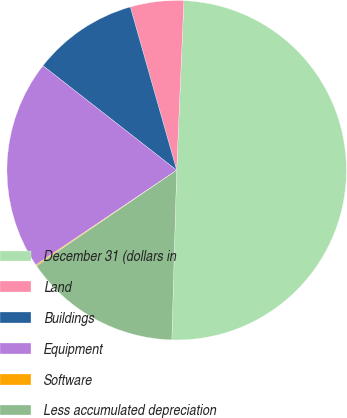Convert chart to OTSL. <chart><loc_0><loc_0><loc_500><loc_500><pie_chart><fcel>December 31 (dollars in<fcel>Land<fcel>Buildings<fcel>Equipment<fcel>Software<fcel>Less accumulated depreciation<nl><fcel>49.78%<fcel>5.08%<fcel>10.04%<fcel>19.98%<fcel>0.11%<fcel>15.01%<nl></chart> 